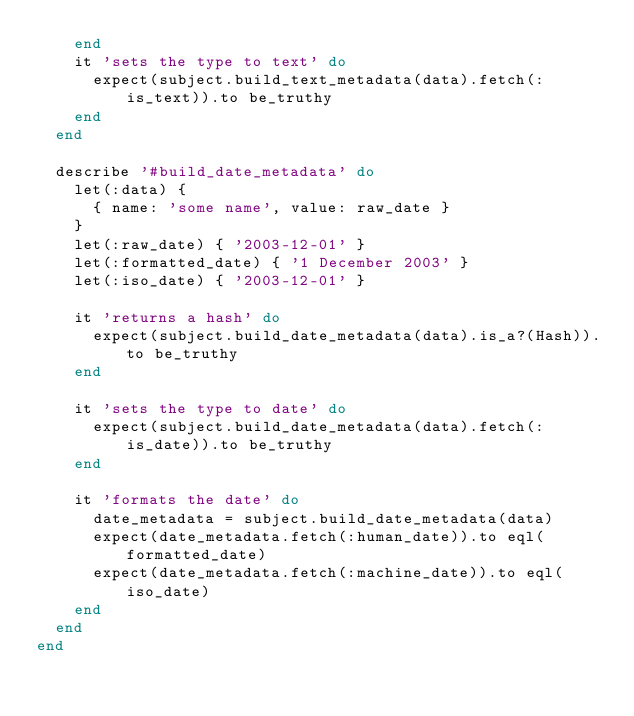Convert code to text. <code><loc_0><loc_0><loc_500><loc_500><_Ruby_>    end
    it 'sets the type to text' do
      expect(subject.build_text_metadata(data).fetch(:is_text)).to be_truthy
    end
  end

  describe '#build_date_metadata' do
    let(:data) {
      { name: 'some name', value: raw_date }
    }
    let(:raw_date) { '2003-12-01' }
    let(:formatted_date) { '1 December 2003' }
    let(:iso_date) { '2003-12-01' }

    it 'returns a hash' do
      expect(subject.build_date_metadata(data).is_a?(Hash)).to be_truthy
    end

    it 'sets the type to date' do
      expect(subject.build_date_metadata(data).fetch(:is_date)).to be_truthy
    end

    it 'formats the date' do
      date_metadata = subject.build_date_metadata(data)
      expect(date_metadata.fetch(:human_date)).to eql(formatted_date)
      expect(date_metadata.fetch(:machine_date)).to eql(iso_date)
    end
  end
end
</code> 